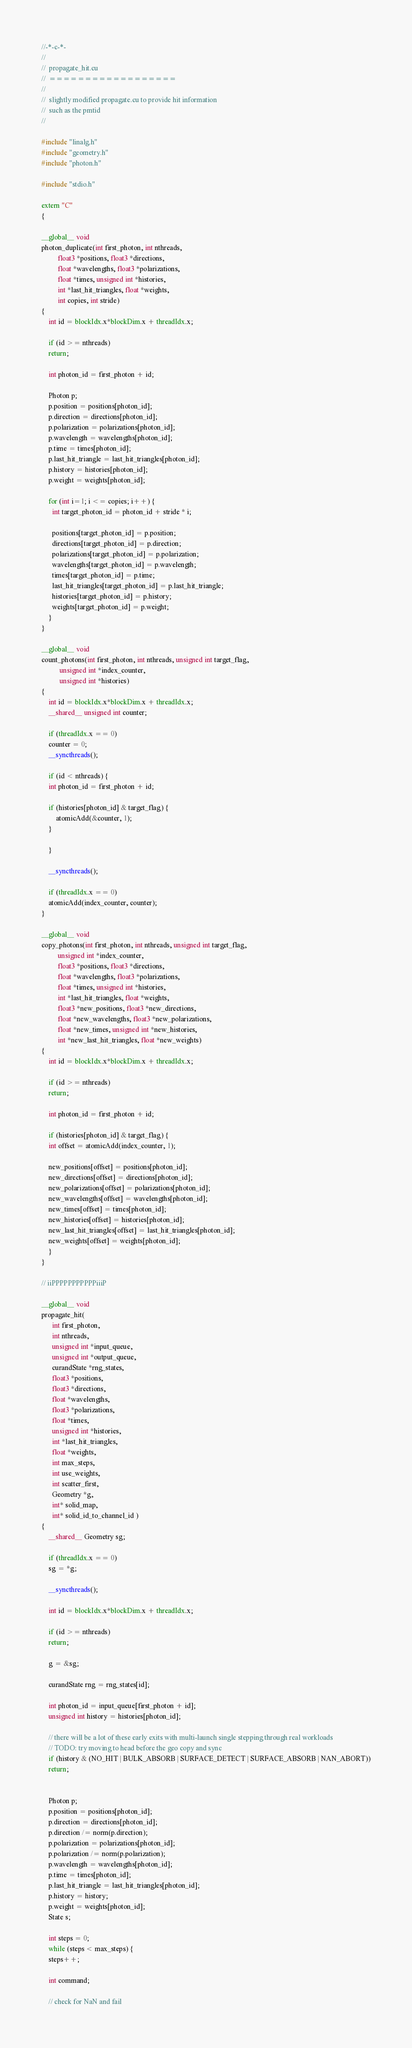<code> <loc_0><loc_0><loc_500><loc_500><_Cuda_>//-*-c-*-
//
//  propagate_hit.cu
//  ==================
//
//  slightly modified propagate.cu to provide hit information
//  such as the pmtid
//

#include "linalg.h"
#include "geometry.h"
#include "photon.h"

#include "stdio.h"

extern "C"
{

__global__ void
photon_duplicate(int first_photon, int nthreads,
		 float3 *positions, float3 *directions,
		 float *wavelengths, float3 *polarizations,
		 float *times, unsigned int *histories,
		 int *last_hit_triangles, float *weights,
		 int copies, int stride)
{
    int id = blockIdx.x*blockDim.x + threadIdx.x;

    if (id >= nthreads)
	return;

    int photon_id = first_photon + id;

    Photon p;
    p.position = positions[photon_id];
    p.direction = directions[photon_id];
    p.polarization = polarizations[photon_id];
    p.wavelength = wavelengths[photon_id];
    p.time = times[photon_id];
    p.last_hit_triangle = last_hit_triangles[photon_id];
    p.history = histories[photon_id];
    p.weight = weights[photon_id];

    for (int i=1; i <= copies; i++) {
      int target_photon_id = photon_id + stride * i;

      positions[target_photon_id] = p.position;
      directions[target_photon_id] = p.direction;
      polarizations[target_photon_id] = p.polarization;
      wavelengths[target_photon_id] = p.wavelength;
      times[target_photon_id] = p.time;
      last_hit_triangles[target_photon_id] = p.last_hit_triangle;
      histories[target_photon_id] = p.history;
      weights[target_photon_id] = p.weight;
    }
}

__global__ void
count_photons(int first_photon, int nthreads, unsigned int target_flag,
	      unsigned int *index_counter,
	      unsigned int *histories)
{
    int id = blockIdx.x*blockDim.x + threadIdx.x;
    __shared__ unsigned int counter;

    if (threadIdx.x == 0)
	counter = 0;
    __syncthreads();

    if (id < nthreads) {
	int photon_id = first_photon + id;

	if (histories[photon_id] & target_flag) {
	    atomicAdd(&counter, 1);
	}
	    
    }

    __syncthreads();

    if (threadIdx.x == 0)
	atomicAdd(index_counter, counter);
}

__global__ void
copy_photons(int first_photon, int nthreads, unsigned int target_flag,
	     unsigned int *index_counter,
	     float3 *positions, float3 *directions,
	     float *wavelengths, float3 *polarizations,
	     float *times, unsigned int *histories,
	     int *last_hit_triangles, float *weights,
	     float3 *new_positions, float3 *new_directions,
	     float *new_wavelengths, float3 *new_polarizations,
	     float *new_times, unsigned int *new_histories,
	     int *new_last_hit_triangles, float *new_weights)
{
    int id = blockIdx.x*blockDim.x + threadIdx.x;
    
    if (id >= nthreads)
	return;
    
    int photon_id = first_photon + id;

    if (histories[photon_id] & target_flag) {
	int offset = atomicAdd(index_counter, 1);

	new_positions[offset] = positions[photon_id];
	new_directions[offset] = directions[photon_id];
	new_polarizations[offset] = polarizations[photon_id];
	new_wavelengths[offset] = wavelengths[photon_id];
	new_times[offset] = times[photon_id];
	new_histories[offset] = histories[photon_id];
	new_last_hit_triangles[offset] = last_hit_triangles[photon_id];
	new_weights[offset] = weights[photon_id];
    }
}

// iiPPPPPPPPPPPiiiP
    
__global__ void
propagate_hit(
      int first_photon, 
      int nthreads, 
      unsigned int *input_queue,
	  unsigned int *output_queue, 
      curandState *rng_states,
	  float3 *positions, 
      float3 *directions,
	  float *wavelengths, 
      float3 *polarizations,
	  float *times, 
      unsigned int *histories,
	  int *last_hit_triangles, 
      float *weights,
	  int max_steps, 
      int use_weights, 
      int scatter_first,
	  Geometry *g,
      int* solid_map, 
      int* solid_id_to_channel_id )
{
    __shared__ Geometry sg;

    if (threadIdx.x == 0)
	sg = *g;

    __syncthreads();

    int id = blockIdx.x*blockDim.x + threadIdx.x;

    if (id >= nthreads)
	return;

    g = &sg;

    curandState rng = rng_states[id];

    int photon_id = input_queue[first_photon + id];
    unsigned int history = histories[photon_id];

    // there will be a lot of these early exits with multi-launch single stepping through real workloads
    // TODO: try moving to head before the geo copy and sync  
    if (history & (NO_HIT | BULK_ABSORB | SURFACE_DETECT | SURFACE_ABSORB | NAN_ABORT))
	return;


    Photon p;
    p.position = positions[photon_id];
    p.direction = directions[photon_id];
    p.direction /= norm(p.direction);
    p.polarization = polarizations[photon_id];
    p.polarization /= norm(p.polarization);
    p.wavelength = wavelengths[photon_id];
    p.time = times[photon_id];
    p.last_hit_triangle = last_hit_triangles[photon_id];
    p.history = history;
    p.weight = weights[photon_id];
    State s;

    int steps = 0;
    while (steps < max_steps) {
	steps++;

	int command;

	// check for NaN and fail</code> 